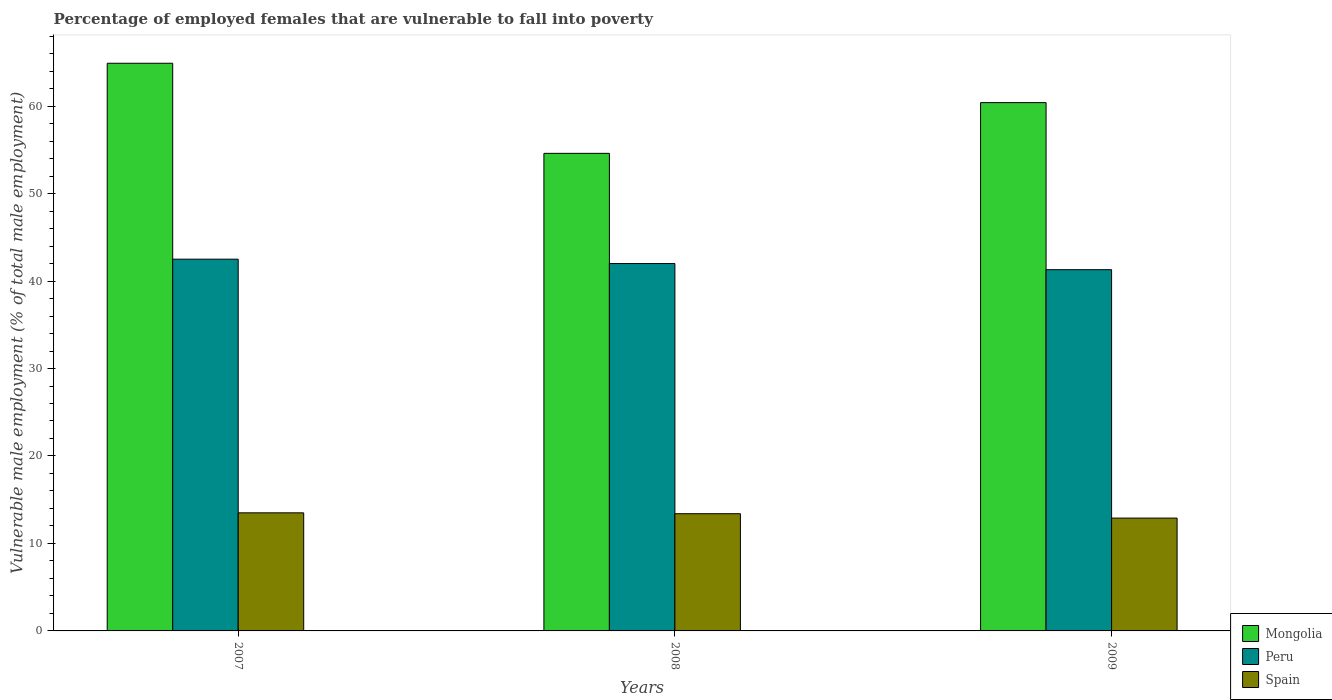How many different coloured bars are there?
Make the answer very short. 3. How many groups of bars are there?
Keep it short and to the point. 3. Are the number of bars per tick equal to the number of legend labels?
Offer a terse response. Yes. How many bars are there on the 2nd tick from the right?
Keep it short and to the point. 3. What is the label of the 3rd group of bars from the left?
Give a very brief answer. 2009. Across all years, what is the minimum percentage of employed females who are vulnerable to fall into poverty in Spain?
Your response must be concise. 12.9. In which year was the percentage of employed females who are vulnerable to fall into poverty in Peru maximum?
Provide a succinct answer. 2007. In which year was the percentage of employed females who are vulnerable to fall into poverty in Peru minimum?
Make the answer very short. 2009. What is the total percentage of employed females who are vulnerable to fall into poverty in Peru in the graph?
Your response must be concise. 125.8. What is the difference between the percentage of employed females who are vulnerable to fall into poverty in Mongolia in 2007 and that in 2009?
Make the answer very short. 4.5. What is the difference between the percentage of employed females who are vulnerable to fall into poverty in Peru in 2007 and the percentage of employed females who are vulnerable to fall into poverty in Mongolia in 2009?
Keep it short and to the point. -17.9. What is the average percentage of employed females who are vulnerable to fall into poverty in Peru per year?
Your response must be concise. 41.93. In the year 2008, what is the difference between the percentage of employed females who are vulnerable to fall into poverty in Mongolia and percentage of employed females who are vulnerable to fall into poverty in Peru?
Give a very brief answer. 12.6. In how many years, is the percentage of employed females who are vulnerable to fall into poverty in Spain greater than 32 %?
Provide a short and direct response. 0. What is the ratio of the percentage of employed females who are vulnerable to fall into poverty in Spain in 2008 to that in 2009?
Offer a very short reply. 1.04. Is the percentage of employed females who are vulnerable to fall into poverty in Mongolia in 2008 less than that in 2009?
Ensure brevity in your answer.  Yes. What is the difference between the highest and the second highest percentage of employed females who are vulnerable to fall into poverty in Mongolia?
Provide a succinct answer. 4.5. What is the difference between the highest and the lowest percentage of employed females who are vulnerable to fall into poverty in Spain?
Make the answer very short. 0.6. Is the sum of the percentage of employed females who are vulnerable to fall into poverty in Mongolia in 2008 and 2009 greater than the maximum percentage of employed females who are vulnerable to fall into poverty in Spain across all years?
Offer a terse response. Yes. Is it the case that in every year, the sum of the percentage of employed females who are vulnerable to fall into poverty in Peru and percentage of employed females who are vulnerable to fall into poverty in Mongolia is greater than the percentage of employed females who are vulnerable to fall into poverty in Spain?
Offer a very short reply. Yes. Are the values on the major ticks of Y-axis written in scientific E-notation?
Give a very brief answer. No. Does the graph contain grids?
Make the answer very short. No. How are the legend labels stacked?
Keep it short and to the point. Vertical. What is the title of the graph?
Offer a very short reply. Percentage of employed females that are vulnerable to fall into poverty. What is the label or title of the X-axis?
Give a very brief answer. Years. What is the label or title of the Y-axis?
Keep it short and to the point. Vulnerable male employment (% of total male employment). What is the Vulnerable male employment (% of total male employment) of Mongolia in 2007?
Keep it short and to the point. 64.9. What is the Vulnerable male employment (% of total male employment) of Peru in 2007?
Provide a short and direct response. 42.5. What is the Vulnerable male employment (% of total male employment) of Spain in 2007?
Offer a very short reply. 13.5. What is the Vulnerable male employment (% of total male employment) of Mongolia in 2008?
Keep it short and to the point. 54.6. What is the Vulnerable male employment (% of total male employment) of Spain in 2008?
Provide a succinct answer. 13.4. What is the Vulnerable male employment (% of total male employment) of Mongolia in 2009?
Keep it short and to the point. 60.4. What is the Vulnerable male employment (% of total male employment) in Peru in 2009?
Your answer should be compact. 41.3. What is the Vulnerable male employment (% of total male employment) in Spain in 2009?
Offer a very short reply. 12.9. Across all years, what is the maximum Vulnerable male employment (% of total male employment) in Mongolia?
Ensure brevity in your answer.  64.9. Across all years, what is the maximum Vulnerable male employment (% of total male employment) of Peru?
Provide a short and direct response. 42.5. Across all years, what is the minimum Vulnerable male employment (% of total male employment) of Mongolia?
Provide a succinct answer. 54.6. Across all years, what is the minimum Vulnerable male employment (% of total male employment) in Peru?
Provide a succinct answer. 41.3. Across all years, what is the minimum Vulnerable male employment (% of total male employment) of Spain?
Your response must be concise. 12.9. What is the total Vulnerable male employment (% of total male employment) of Mongolia in the graph?
Your response must be concise. 179.9. What is the total Vulnerable male employment (% of total male employment) in Peru in the graph?
Make the answer very short. 125.8. What is the total Vulnerable male employment (% of total male employment) of Spain in the graph?
Your answer should be very brief. 39.8. What is the difference between the Vulnerable male employment (% of total male employment) of Mongolia in 2007 and that in 2008?
Your response must be concise. 10.3. What is the difference between the Vulnerable male employment (% of total male employment) in Mongolia in 2007 and that in 2009?
Your answer should be very brief. 4.5. What is the difference between the Vulnerable male employment (% of total male employment) of Peru in 2007 and that in 2009?
Offer a terse response. 1.2. What is the difference between the Vulnerable male employment (% of total male employment) in Peru in 2008 and that in 2009?
Your answer should be very brief. 0.7. What is the difference between the Vulnerable male employment (% of total male employment) of Spain in 2008 and that in 2009?
Your answer should be very brief. 0.5. What is the difference between the Vulnerable male employment (% of total male employment) of Mongolia in 2007 and the Vulnerable male employment (% of total male employment) of Peru in 2008?
Provide a succinct answer. 22.9. What is the difference between the Vulnerable male employment (% of total male employment) of Mongolia in 2007 and the Vulnerable male employment (% of total male employment) of Spain in 2008?
Your answer should be compact. 51.5. What is the difference between the Vulnerable male employment (% of total male employment) in Peru in 2007 and the Vulnerable male employment (% of total male employment) in Spain in 2008?
Give a very brief answer. 29.1. What is the difference between the Vulnerable male employment (% of total male employment) of Mongolia in 2007 and the Vulnerable male employment (% of total male employment) of Peru in 2009?
Your answer should be very brief. 23.6. What is the difference between the Vulnerable male employment (% of total male employment) of Peru in 2007 and the Vulnerable male employment (% of total male employment) of Spain in 2009?
Offer a very short reply. 29.6. What is the difference between the Vulnerable male employment (% of total male employment) of Mongolia in 2008 and the Vulnerable male employment (% of total male employment) of Spain in 2009?
Your response must be concise. 41.7. What is the difference between the Vulnerable male employment (% of total male employment) in Peru in 2008 and the Vulnerable male employment (% of total male employment) in Spain in 2009?
Your answer should be compact. 29.1. What is the average Vulnerable male employment (% of total male employment) in Mongolia per year?
Your answer should be compact. 59.97. What is the average Vulnerable male employment (% of total male employment) of Peru per year?
Keep it short and to the point. 41.93. What is the average Vulnerable male employment (% of total male employment) in Spain per year?
Provide a short and direct response. 13.27. In the year 2007, what is the difference between the Vulnerable male employment (% of total male employment) of Mongolia and Vulnerable male employment (% of total male employment) of Peru?
Make the answer very short. 22.4. In the year 2007, what is the difference between the Vulnerable male employment (% of total male employment) in Mongolia and Vulnerable male employment (% of total male employment) in Spain?
Give a very brief answer. 51.4. In the year 2008, what is the difference between the Vulnerable male employment (% of total male employment) of Mongolia and Vulnerable male employment (% of total male employment) of Peru?
Offer a very short reply. 12.6. In the year 2008, what is the difference between the Vulnerable male employment (% of total male employment) in Mongolia and Vulnerable male employment (% of total male employment) in Spain?
Offer a terse response. 41.2. In the year 2008, what is the difference between the Vulnerable male employment (% of total male employment) of Peru and Vulnerable male employment (% of total male employment) of Spain?
Provide a succinct answer. 28.6. In the year 2009, what is the difference between the Vulnerable male employment (% of total male employment) in Mongolia and Vulnerable male employment (% of total male employment) in Peru?
Offer a terse response. 19.1. In the year 2009, what is the difference between the Vulnerable male employment (% of total male employment) in Mongolia and Vulnerable male employment (% of total male employment) in Spain?
Provide a succinct answer. 47.5. In the year 2009, what is the difference between the Vulnerable male employment (% of total male employment) of Peru and Vulnerable male employment (% of total male employment) of Spain?
Ensure brevity in your answer.  28.4. What is the ratio of the Vulnerable male employment (% of total male employment) in Mongolia in 2007 to that in 2008?
Your answer should be very brief. 1.19. What is the ratio of the Vulnerable male employment (% of total male employment) in Peru in 2007 to that in 2008?
Keep it short and to the point. 1.01. What is the ratio of the Vulnerable male employment (% of total male employment) in Spain in 2007 to that in 2008?
Make the answer very short. 1.01. What is the ratio of the Vulnerable male employment (% of total male employment) of Mongolia in 2007 to that in 2009?
Provide a short and direct response. 1.07. What is the ratio of the Vulnerable male employment (% of total male employment) in Peru in 2007 to that in 2009?
Keep it short and to the point. 1.03. What is the ratio of the Vulnerable male employment (% of total male employment) in Spain in 2007 to that in 2009?
Your answer should be compact. 1.05. What is the ratio of the Vulnerable male employment (% of total male employment) of Mongolia in 2008 to that in 2009?
Your answer should be compact. 0.9. What is the ratio of the Vulnerable male employment (% of total male employment) of Peru in 2008 to that in 2009?
Your answer should be compact. 1.02. What is the ratio of the Vulnerable male employment (% of total male employment) in Spain in 2008 to that in 2009?
Your answer should be compact. 1.04. What is the difference between the highest and the second highest Vulnerable male employment (% of total male employment) in Mongolia?
Your response must be concise. 4.5. What is the difference between the highest and the second highest Vulnerable male employment (% of total male employment) in Peru?
Offer a very short reply. 0.5. What is the difference between the highest and the second highest Vulnerable male employment (% of total male employment) of Spain?
Ensure brevity in your answer.  0.1. What is the difference between the highest and the lowest Vulnerable male employment (% of total male employment) in Mongolia?
Make the answer very short. 10.3. 